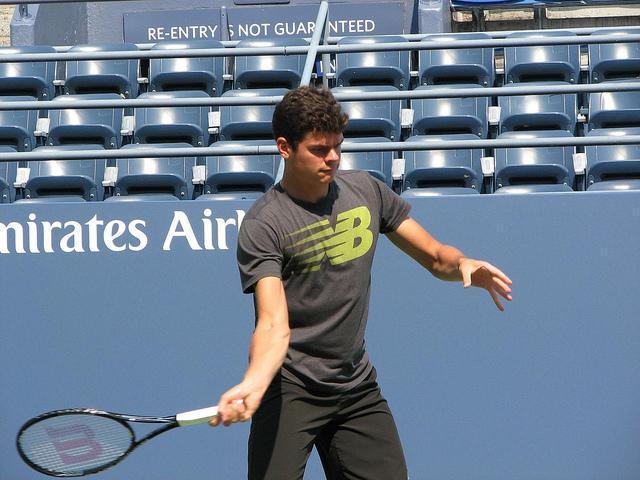How many chairs are there?
Give a very brief answer. 12. 